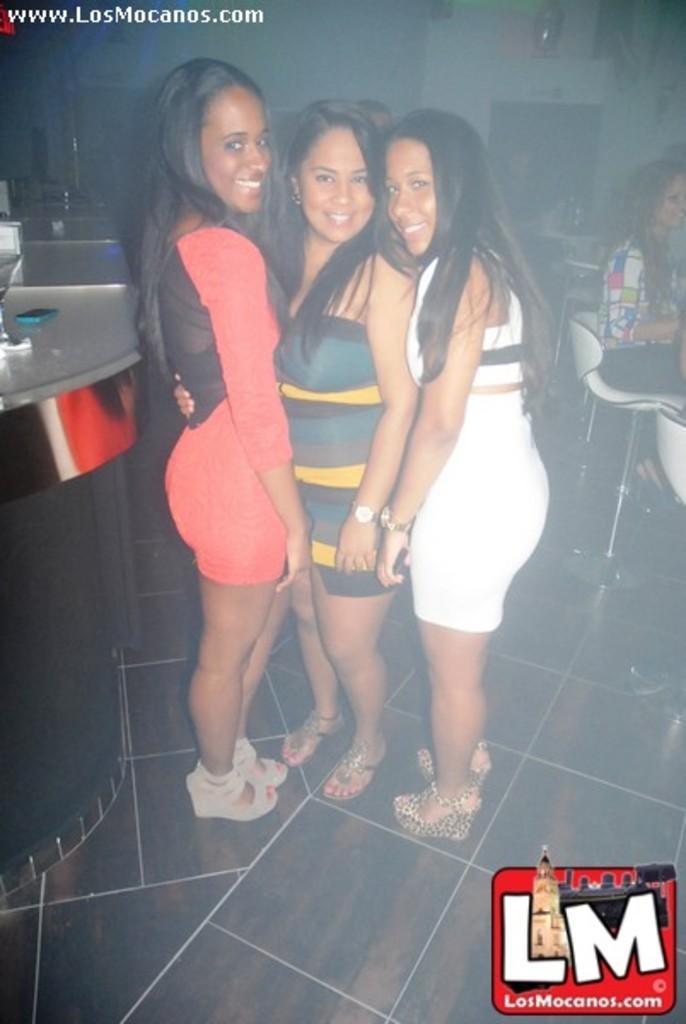Please provide a concise description of this image. In this image I see 3 women who are standing and I see that all of them are smiling and I see the floor. In the background I see few chairs and I see few people and I see few things over here and I see the wall and I see the watermark on the top and on the bottom. 